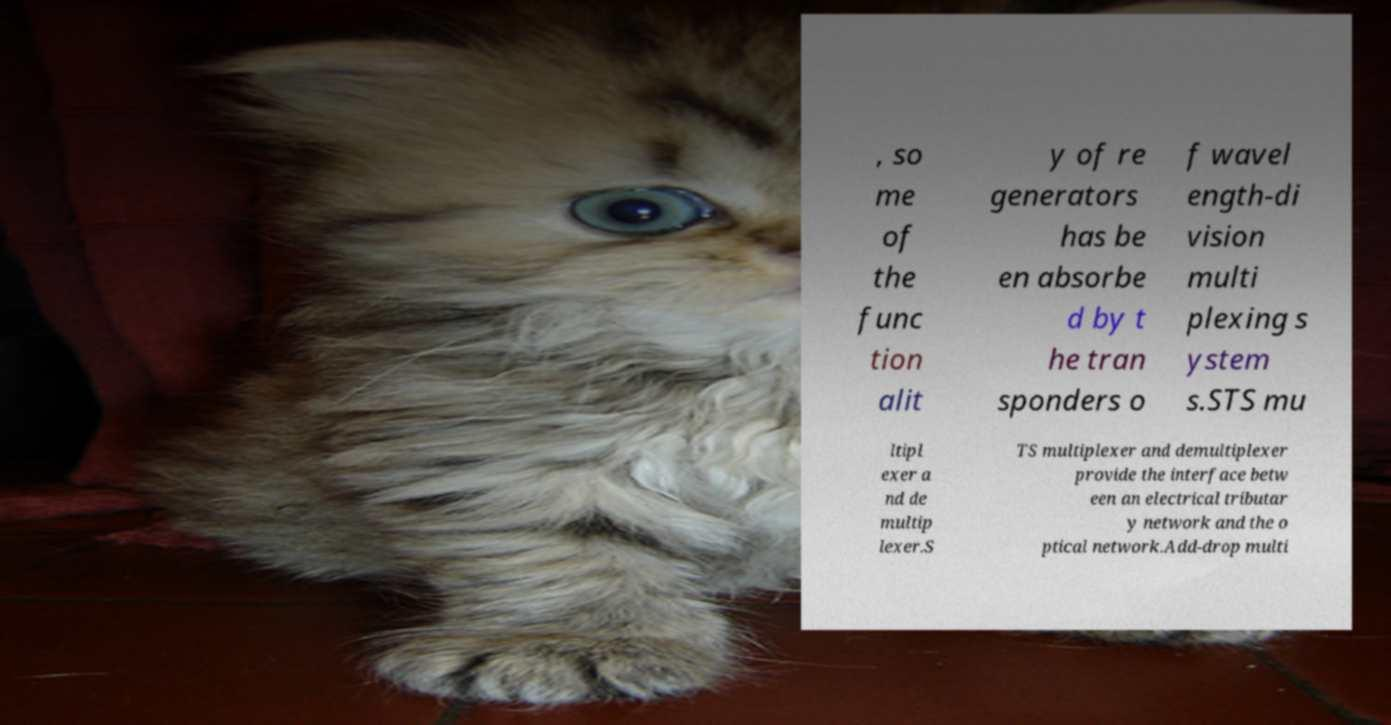Can you accurately transcribe the text from the provided image for me? , so me of the func tion alit y of re generators has be en absorbe d by t he tran sponders o f wavel ength-di vision multi plexing s ystem s.STS mu ltipl exer a nd de multip lexer.S TS multiplexer and demultiplexer provide the interface betw een an electrical tributar y network and the o ptical network.Add-drop multi 